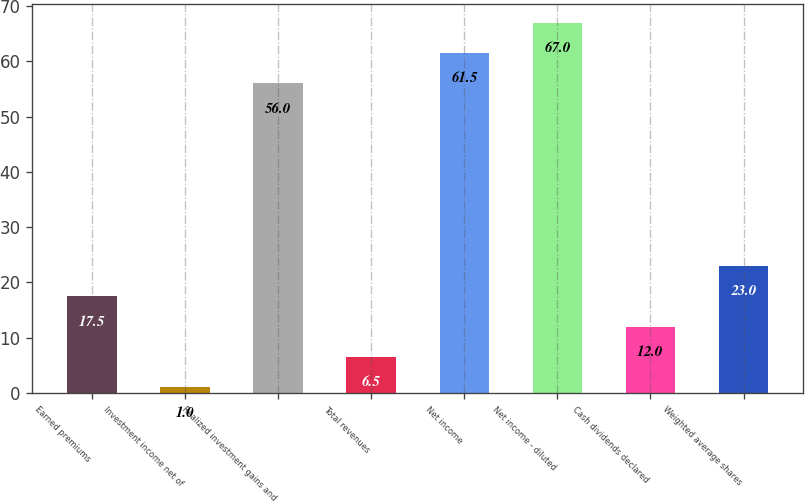Convert chart. <chart><loc_0><loc_0><loc_500><loc_500><bar_chart><fcel>Earned premiums<fcel>Investment income net of<fcel>Realized investment gains and<fcel>Total revenues<fcel>Net income<fcel>Net income - diluted<fcel>Cash dividends declared<fcel>Weighted average shares<nl><fcel>17.5<fcel>1<fcel>56<fcel>6.5<fcel>61.5<fcel>67<fcel>12<fcel>23<nl></chart> 